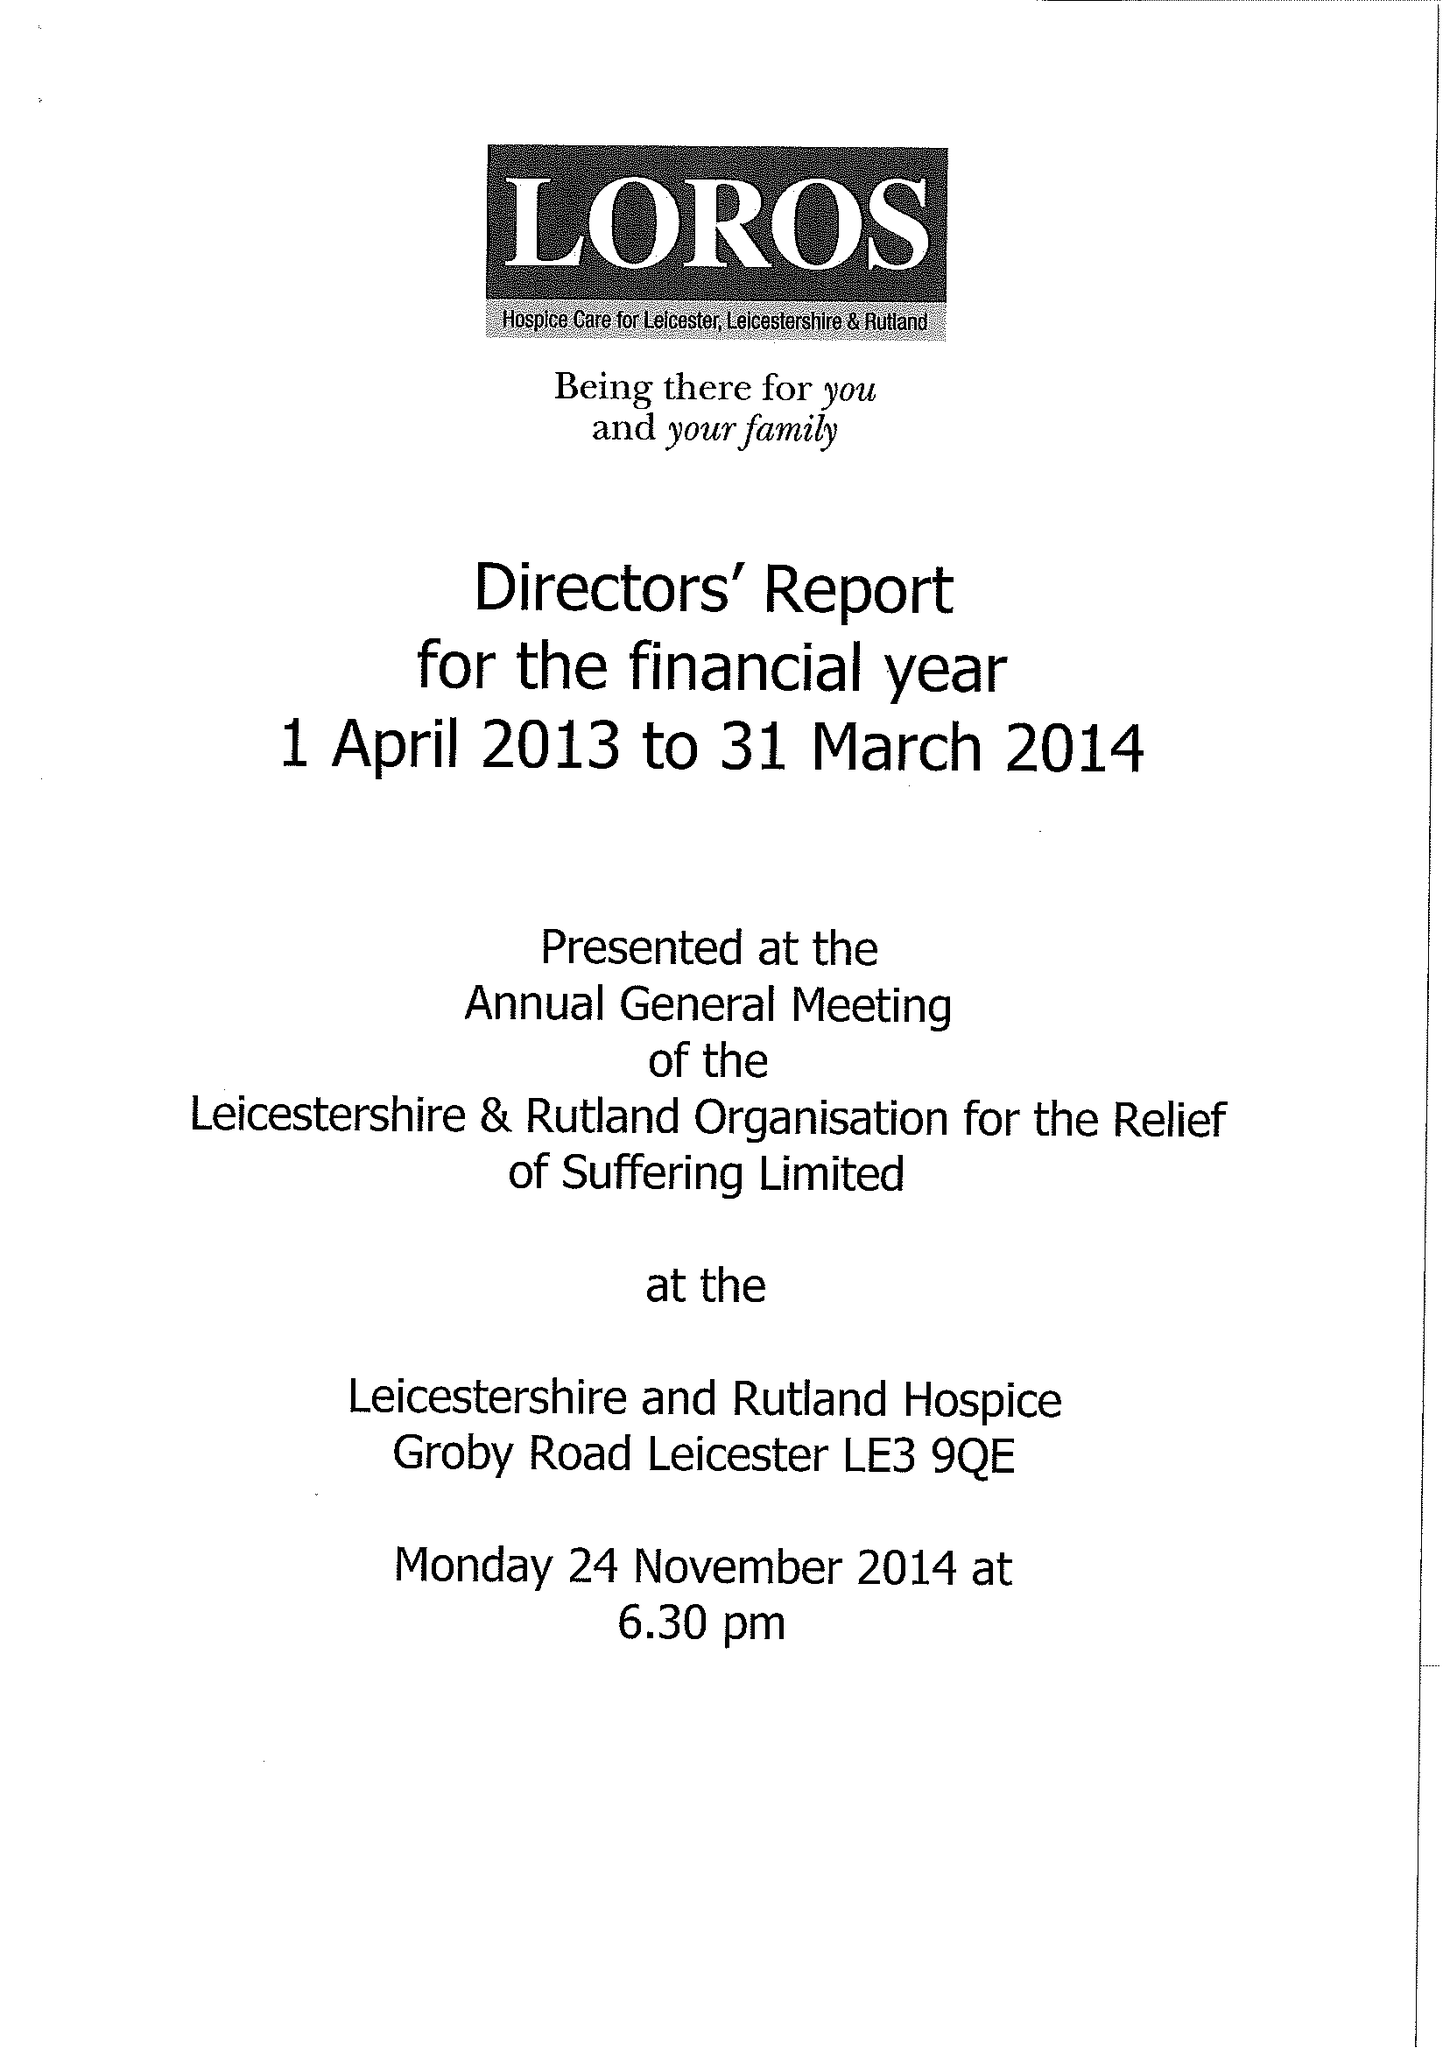What is the value for the address__postcode?
Answer the question using a single word or phrase. LE3 9QE 